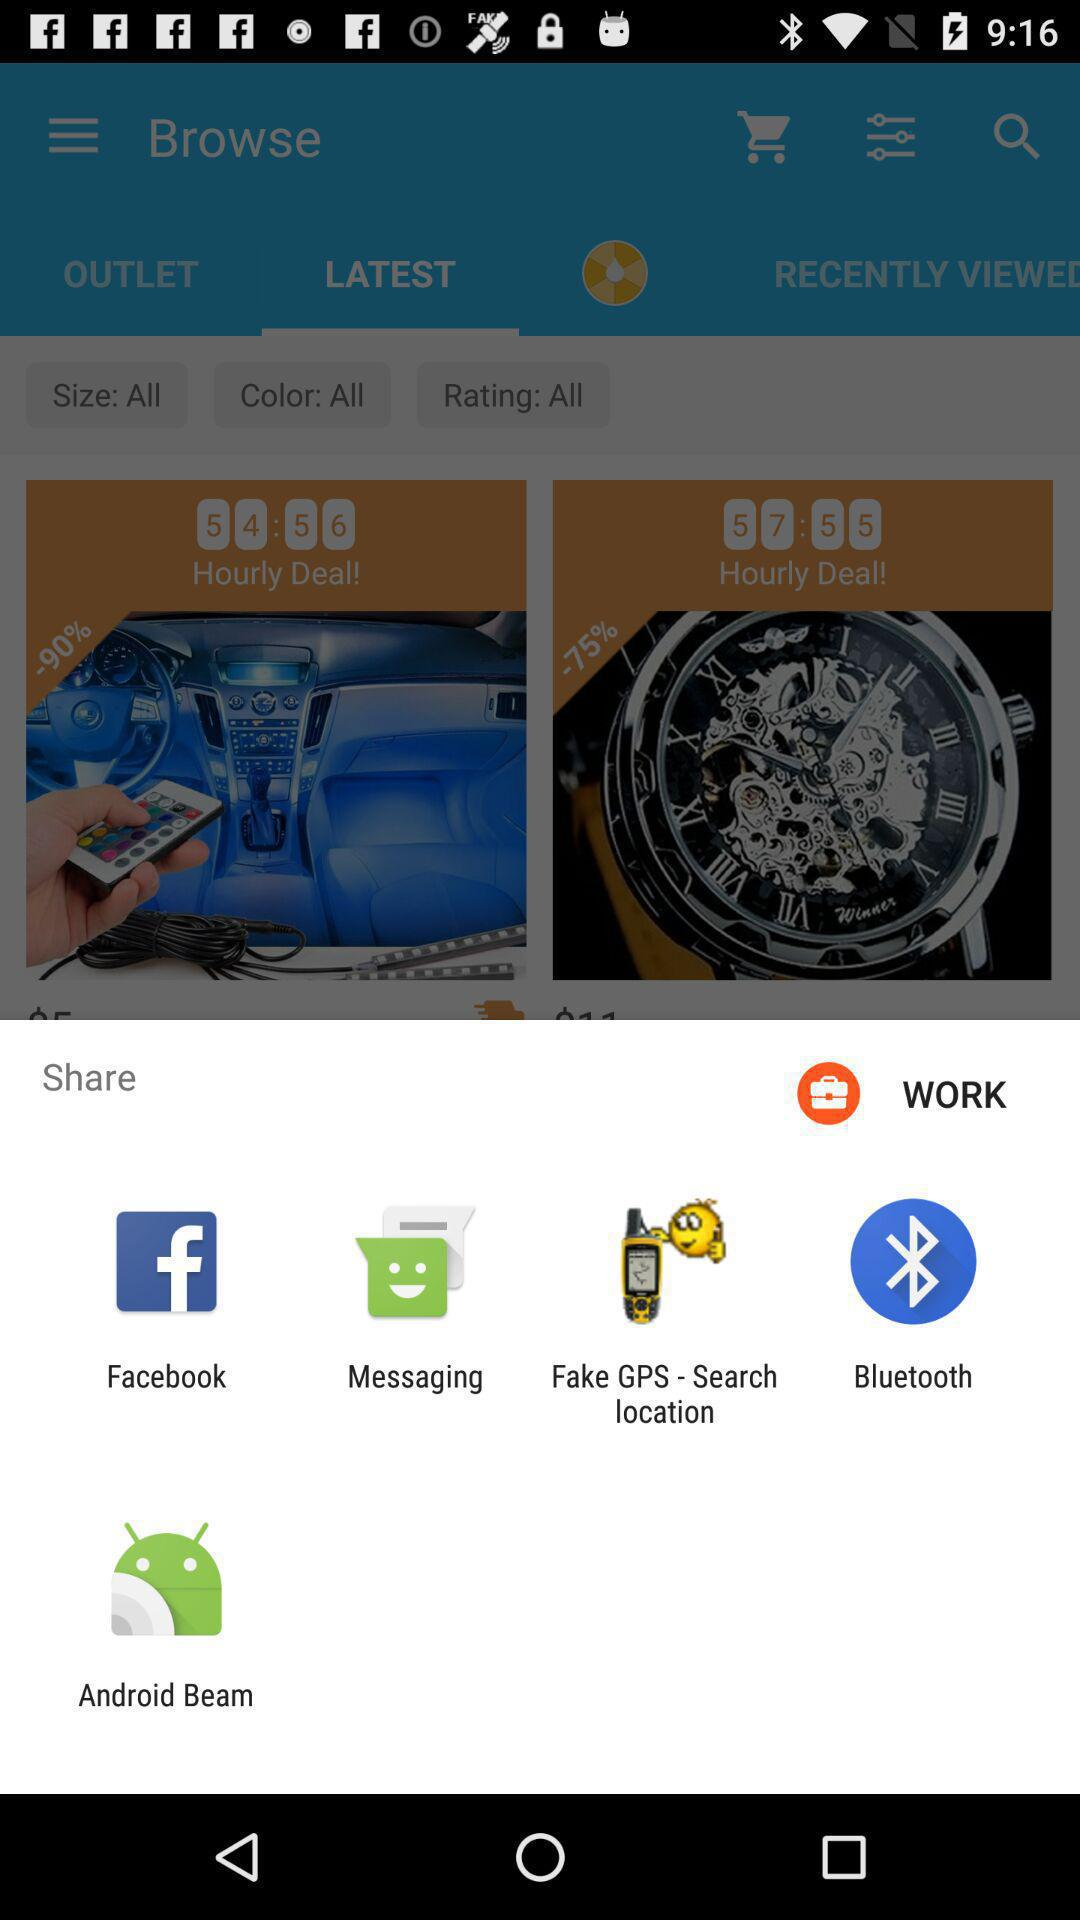What are the different mediums to share? The different mediums to share are "Facebook", "Messaging", "Fake GPS - Search location", "Bluetooth" and "Android Beam". 